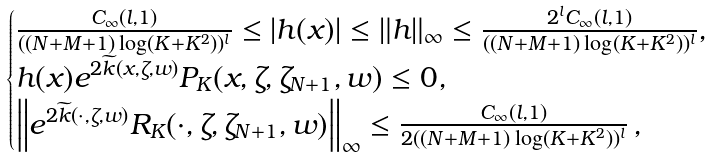Convert formula to latex. <formula><loc_0><loc_0><loc_500><loc_500>\begin{cases} \frac { C _ { \infty } ( l , 1 ) } { ( ( N + M + 1 ) \log ( K + K ^ { 2 } ) ) ^ { l } } \leq | h ( x ) | \leq \| h \| _ { \infty } \leq \frac { 2 ^ { l } C _ { \infty } ( l , 1 ) } { ( ( N + M + 1 ) \log ( K + K ^ { 2 } ) ) ^ { l } } , \\ h ( x ) e ^ { 2 \widetilde { k } ( x , \zeta , w ) } P _ { K } ( x , \zeta , \zeta _ { N + 1 } , w ) \leq 0 , \\ \left \| e ^ { 2 \widetilde { k } ( \cdot , \zeta , w ) } R _ { K } ( \cdot , \zeta , \zeta _ { N + 1 } , w ) \right \| _ { \infty } \leq \frac { C _ { \infty } ( l , 1 ) } { 2 ( ( N + M + 1 ) \log ( K + K ^ { 2 } ) ) ^ { l } } \, , \end{cases}</formula> 